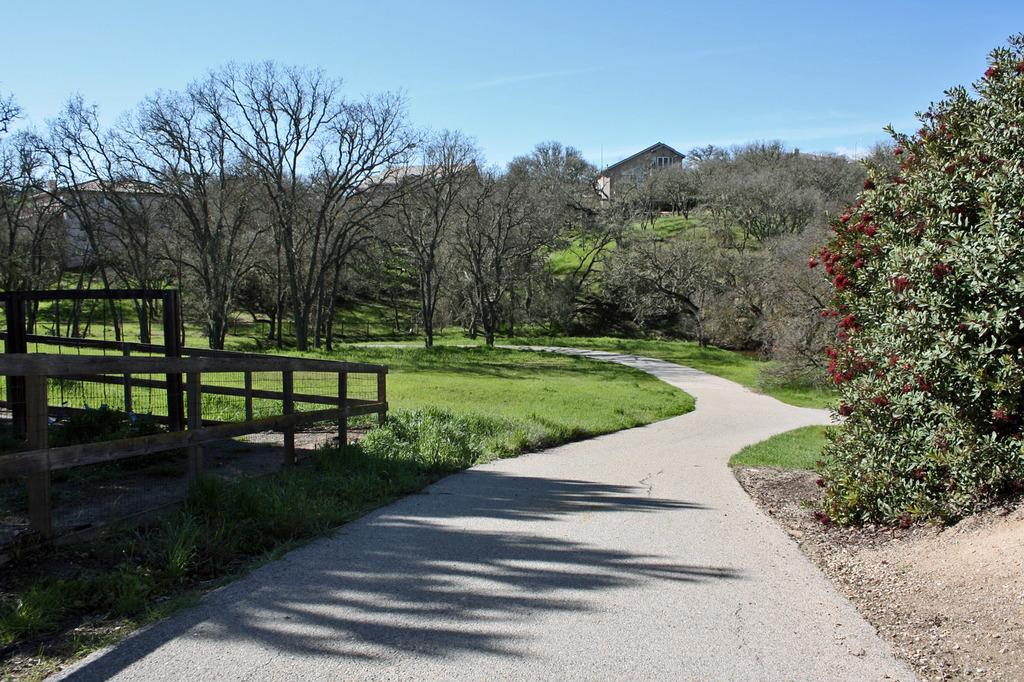What can be seen running through the center of the image? There is a path in the image. What type of vegetation is present alongside the path? There are trees on either side of the path. What is located on the left side of the path? There is fencing on the left side of the path. What structures can be seen in the distance? There are houses in the background of the image. What color is the sky in the background of the image? The sky is blue in the background of the image. Can you tell me how many cows are grazing on the butter in the image? There are no cows or butter present in the image. 